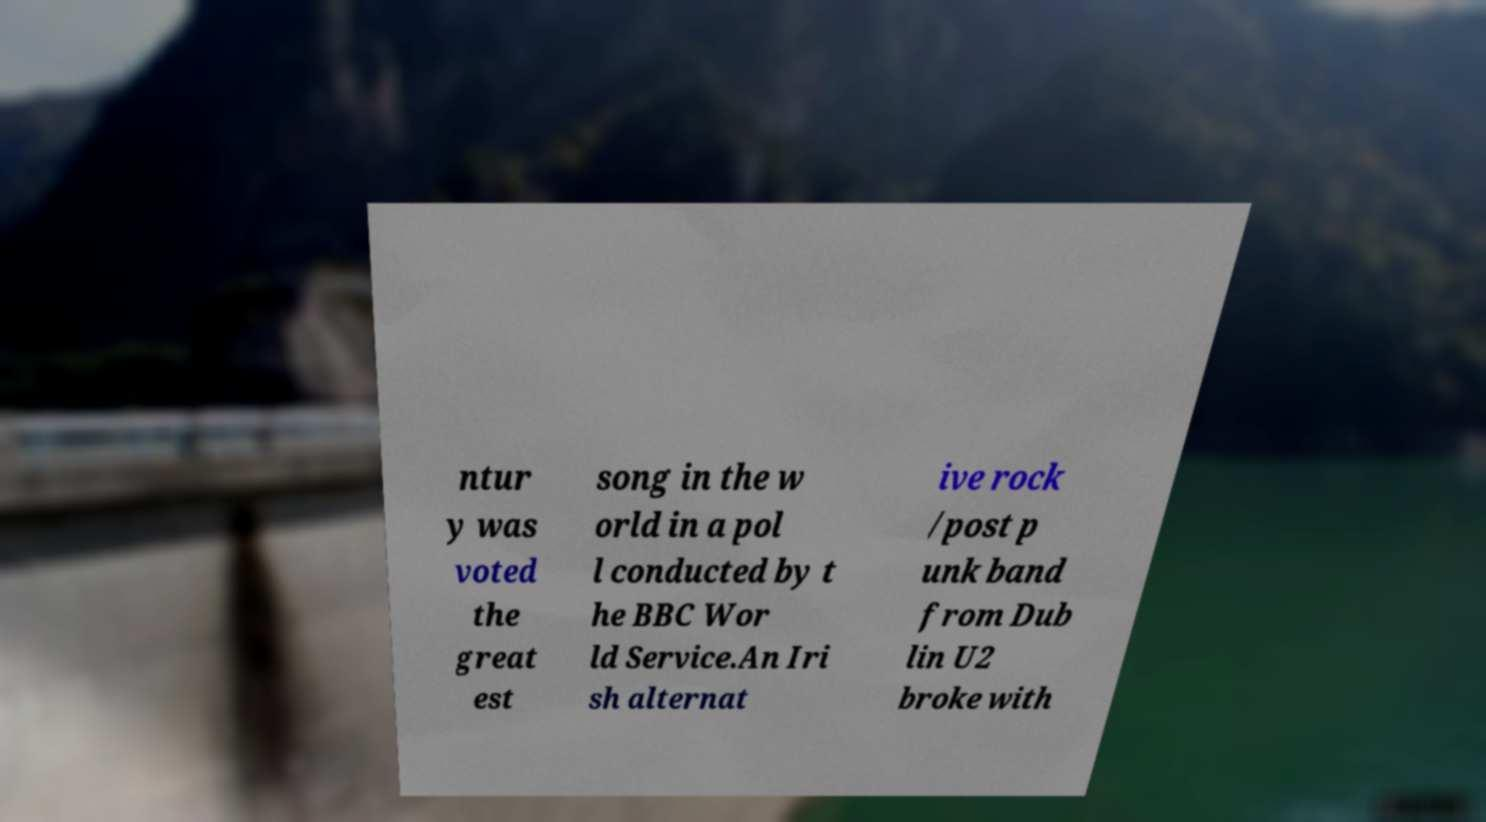What messages or text are displayed in this image? I need them in a readable, typed format. ntur y was voted the great est song in the w orld in a pol l conducted by t he BBC Wor ld Service.An Iri sh alternat ive rock /post p unk band from Dub lin U2 broke with 